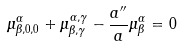<formula> <loc_0><loc_0><loc_500><loc_500>\mu ^ { \alpha } _ { \beta , 0 , 0 } + \mu ^ { \alpha , \gamma } _ { \beta , \gamma } - \frac { a ^ { \prime \prime } } { a } \mu ^ { \alpha } _ { \beta } = 0</formula> 